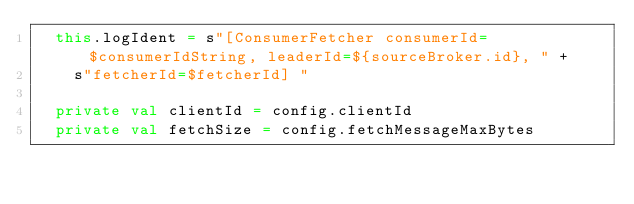<code> <loc_0><loc_0><loc_500><loc_500><_Scala_>  this.logIdent = s"[ConsumerFetcher consumerId=$consumerIdString, leaderId=${sourceBroker.id}, " +
    s"fetcherId=$fetcherId] "

  private val clientId = config.clientId
  private val fetchSize = config.fetchMessageMaxBytes
</code> 